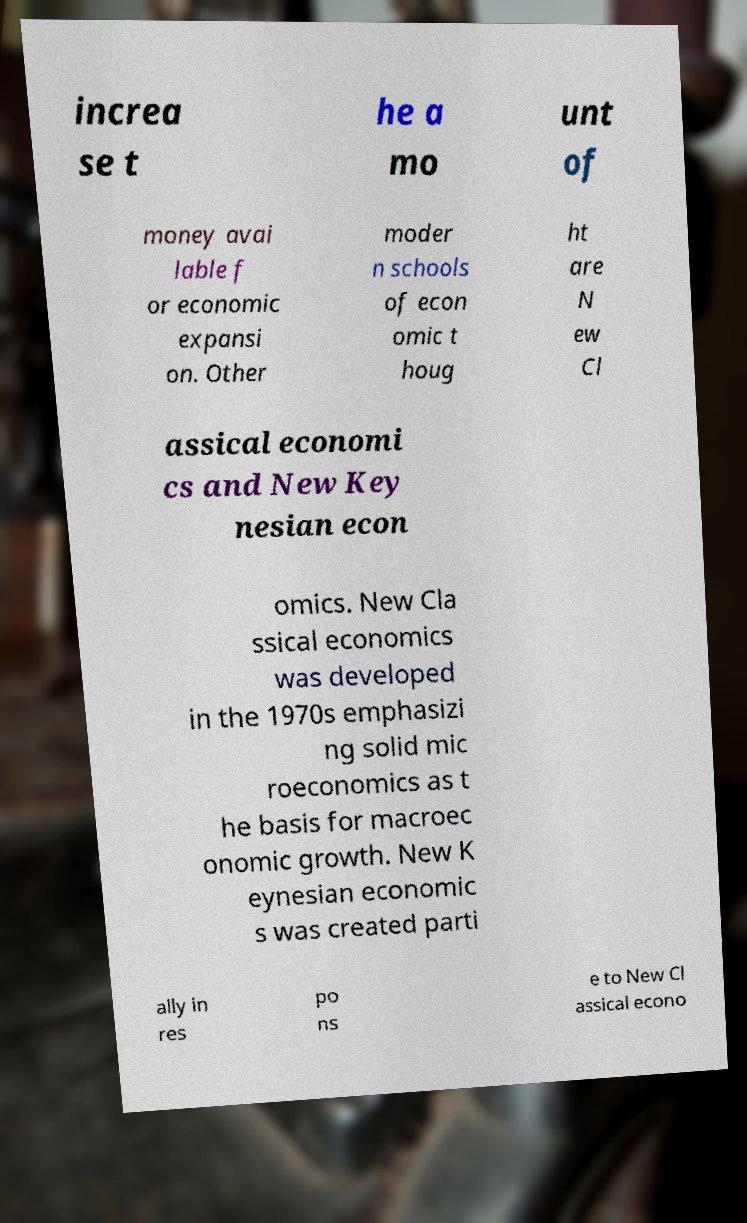Could you extract and type out the text from this image? increa se t he a mo unt of money avai lable f or economic expansi on. Other moder n schools of econ omic t houg ht are N ew Cl assical economi cs and New Key nesian econ omics. New Cla ssical economics was developed in the 1970s emphasizi ng solid mic roeconomics as t he basis for macroec onomic growth. New K eynesian economic s was created parti ally in res po ns e to New Cl assical econo 